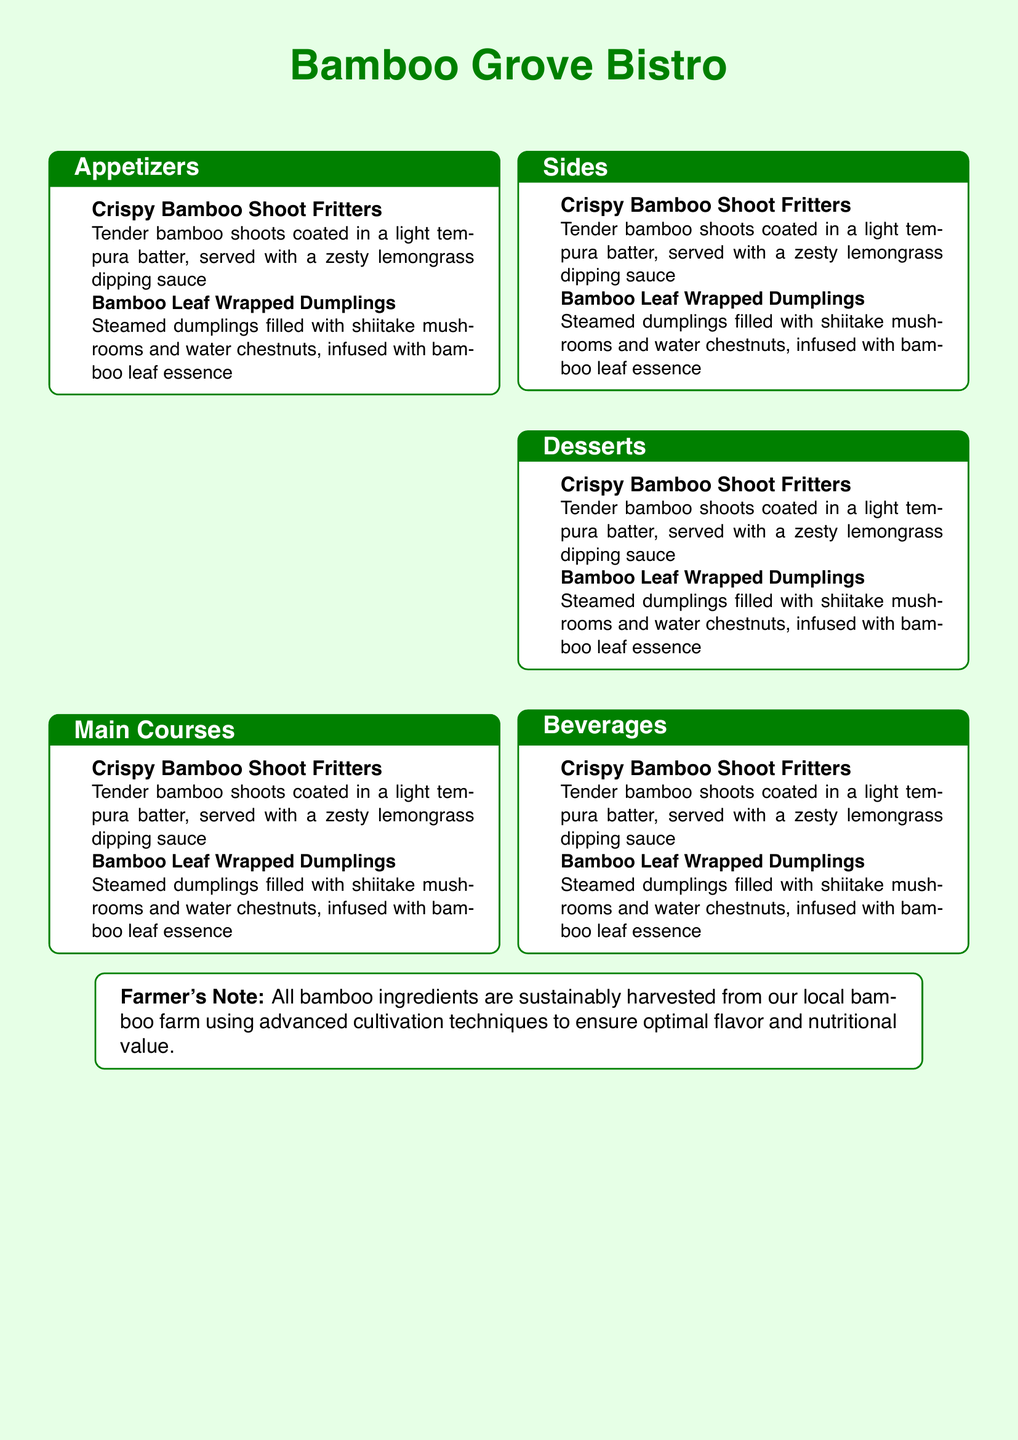What is the name of the restaurant? The restaurant's name is prominently displayed at the top of the document.
Answer: Bamboo Grove Bistro How many sections are featured on the menu? The document outlines multiple sections, specifically identified through their headings.
Answer: Five What is one appetizer listed on the menu? Appetizers are specifically mentioned in the first section, and examples are provided.
Answer: Crispy Bamboo Shoot Fritters What is the main ingredient in the Bamboo Leaf Wrapped Dumplings? The filling of the dumplings is specified in the description under appetizers.
Answer: Shiitake mushrooms and water chestnuts What color is used for the restaurant name? The color of the text for the restaurant name is described in the formatting of the document.
Answer: Bamboogreen What style of cooking is used for the Bamboo Leaf Wrapped Dumplings? The cooking method is mentioned explicitly in the description of the dumplings.
Answer: Steamed What does the Farmer's Note highlight about the bamboo ingredients? The Farmer's Note focuses on the sourcing and sustainability of the bamboo ingredients.
Answer: Sustainably harvested What type of sauce accompanies the Crispy Bamboo Shoot Fritters? The accompanying sauce is mentioned alongside the description of the fritters.
Answer: Zesty lemongrass dipping sauce Which part of the bamboo plant is used in the appetizers? The dishes specifically reference different bamboo parts in their descriptions.
Answer: Bamboo shoots and bamboo leaves 